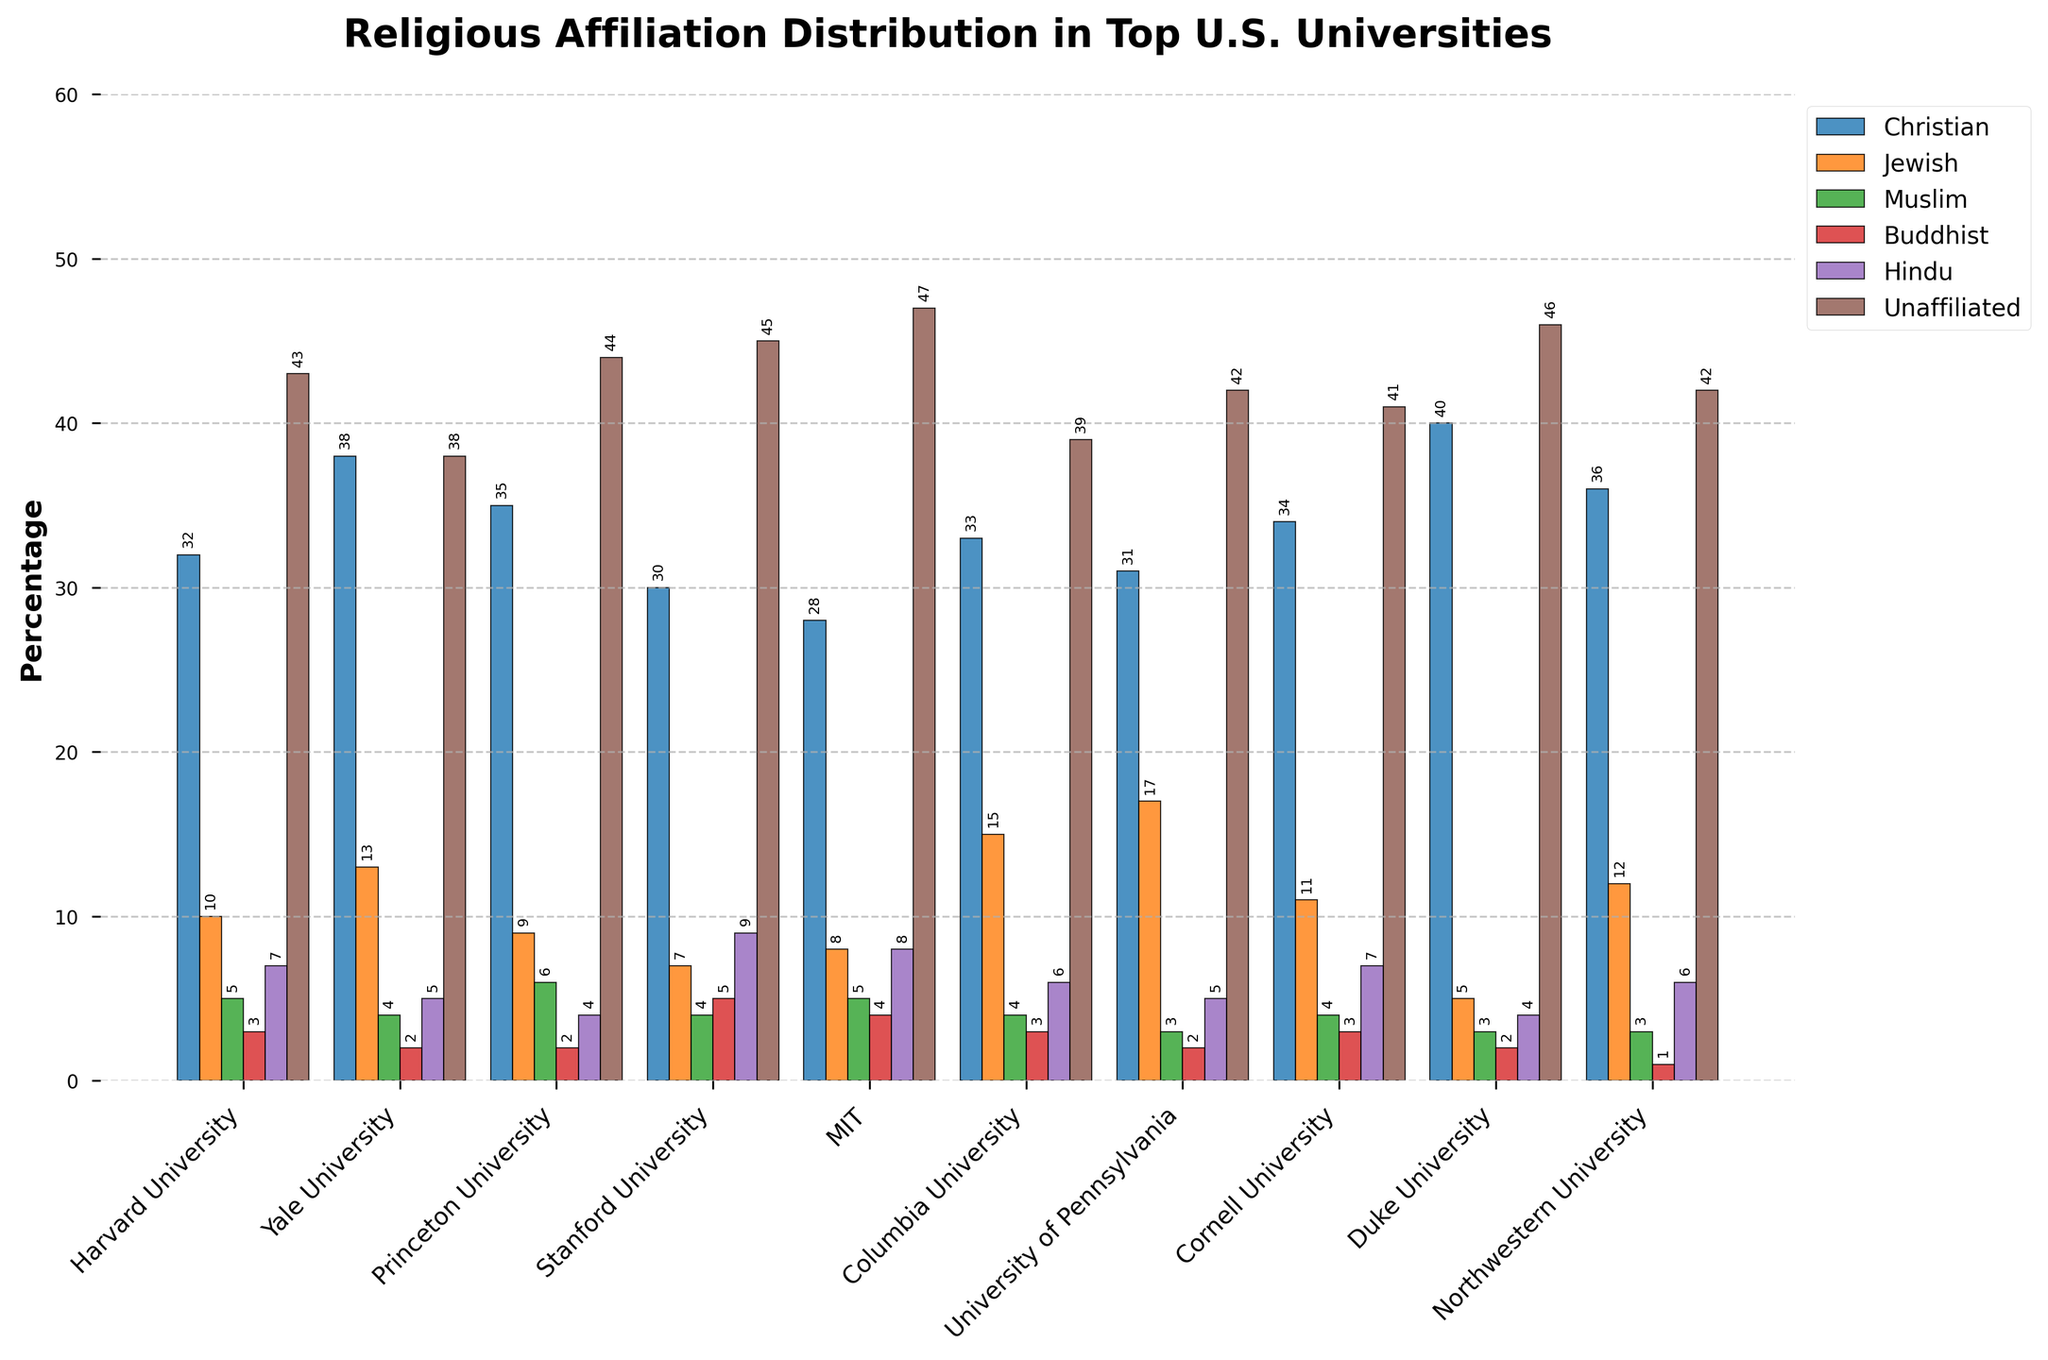What is the total percentage of Christian students at Harvard University and Stanford University? First, find the percentage of Christian students at Harvard University, which is 32%, and at Stanford University, which is 30%. Add these two percentages together: 32 + 30 = 62.
Answer: 62 Which university has the highest percentage of unaffiliated students? Look at the heights of the bars representing unaffiliated students for all universities. Stanford University has the highest bar for unaffiliated students at 45%.
Answer: Stanford University Between Yale University and Columbia University, which has more Jewish students? Yale University has 13% Jewish students, while Columbia University has 15% Jewish students. Since 15% is greater than 13%, Columbia University has more Jewish students.
Answer: Columbia University How many universities have a percentage of Christian students higher than 35%? Identify the universities with Christian student percentages above 35%: Yale University (38%), Duke University (40%), Northwestern University (36%). Therefore, three universities have more than 35%.
Answer: 3 What is the average percentage of Muslim students across all universities? Find the percentages of Muslim students for each university: 5, 4, 6, 4, 5, 4, 3, 4, 3, 3. Add these values together: 5 + 4 + 6 + 4 + 5 + 4 + 3 + 4 + 3 + 3 = 41. Then, divide by the number of universities, which is 10: 41 / 10 = 4.1.
Answer: 4.1 Which university has the lowest percentage of Buddhist students, and what is that percentage? Compare the heights of the bars representing Buddhist students for all universities. Northwestern University has the lowest bar, representing 1%.
Answer: Northwestern University, 1% If you add the percentages of Hindu students at MIT and Cornell University, what would the result be? MIT has 8% Hindu students and Cornell University has 7% Hindu students. Adding them together, 8 + 7 = 15.
Answer: 15 What is the percentage difference between the Christian students at Princeton University and Duke University? Princeton University has 35% Christian students and Duke University has 40%. The difference is 40 - 35 = 5.
Answer: 5 Which university has the most diverse religious distribution based on the visual analysis of the heights of the bars? For the most diverse distribution, look for a university where the heights of the bars are relatively balanced. Columbia University has relatively balanced bar heights across different religions, indicating the most diverse distribution.
Answer: Columbia University 